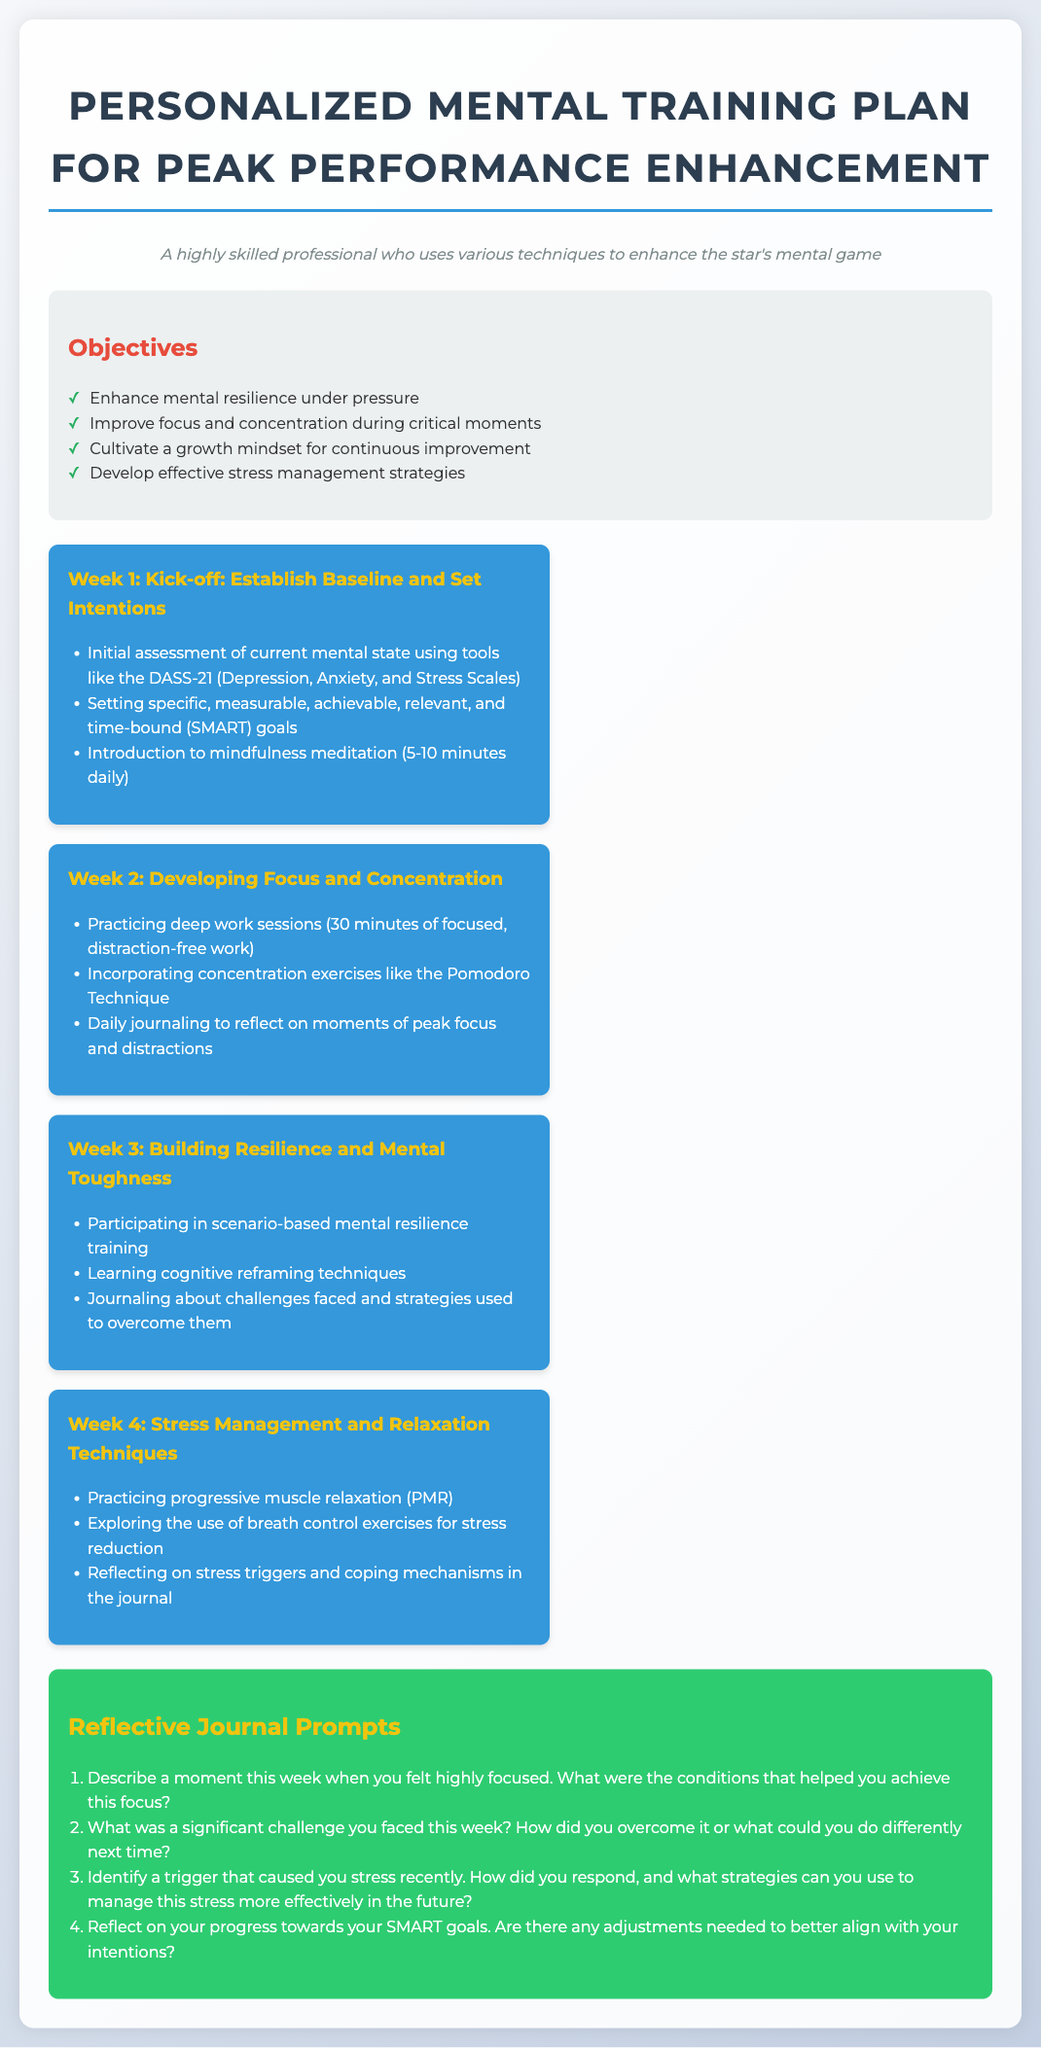What are the main objectives of the training plan? The objectives are listed in a bulleted format in the document under "Objectives".
Answer: Enhance mental resilience under pressure, Improve focus and concentration during critical moments, Cultivate a growth mindset for continuous improvement, Develop effective stress management strategies How many weeks are included in the training plan? The document outlines a plan consisting of four distinct weeks, each with specific goals.
Answer: Four weeks What technique is introduced in Week 1? The first week includes an introduction to a specific mental training technique, which is highlighted in the content.
Answer: Mindfulness meditation What type of exercises are suggested in Week 4 for stress management? Specific types of exercises are mentioned in the weekly goals section of Week 4 which focus on managing stress.
Answer: Progressive muscle relaxation What is the purpose of the reflective journal prompts? The reflective journal prompts are designed to encourage self-reflection on experiences and challenges throughout the training process.
Answer: Self-reflection What should participants do in Week 2 for better concentration? The plan includes a specific method to improve concentration which is provided as part of the weekly goals.
Answer: Pomodoro Technique How many reflective journal prompts are provided in the document? The total number of prompts listed under the reflective prompts section should be counted to find the answer.
Answer: Four prompts Identify a challenge mentioned in the reflective journal prompts. The prompts suggest participants reflect on significant challenges faced each week as part of their journaling process.
Answer: Significant challenge 